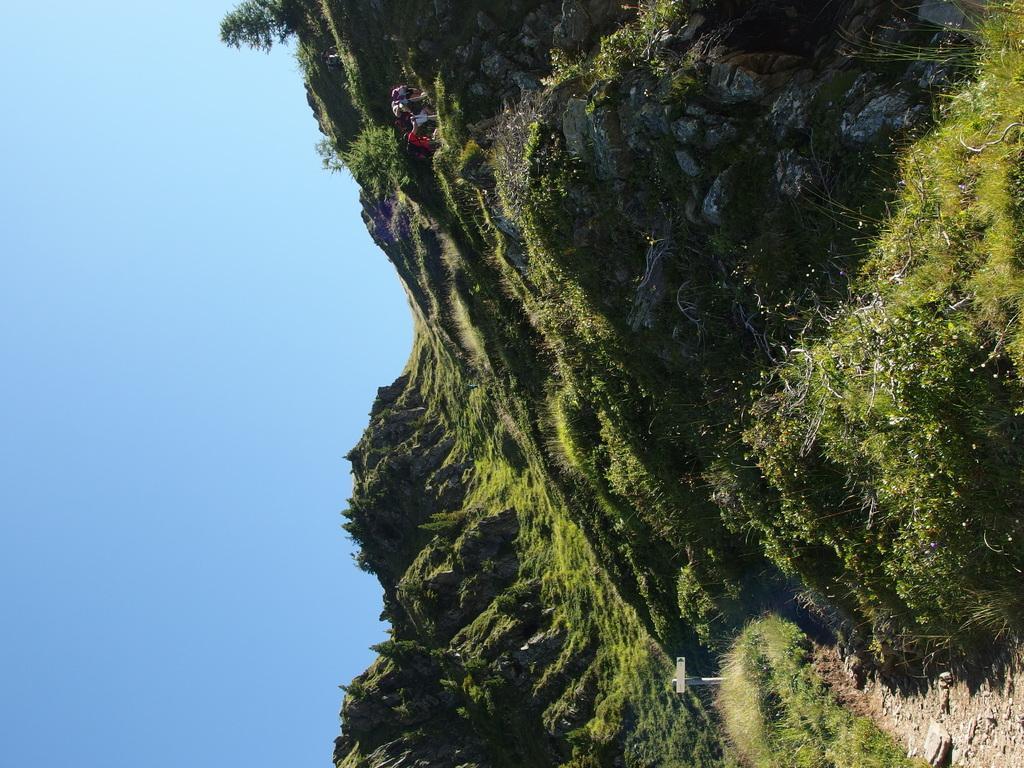In one or two sentences, can you explain what this image depicts? On the right side, we see the grass and the shrubs. Beside that, we see small stones. At the top, we see people are standing. In the middle of the picture, we see trees and hills. On the left side, we see the sky, which is blue in color. 